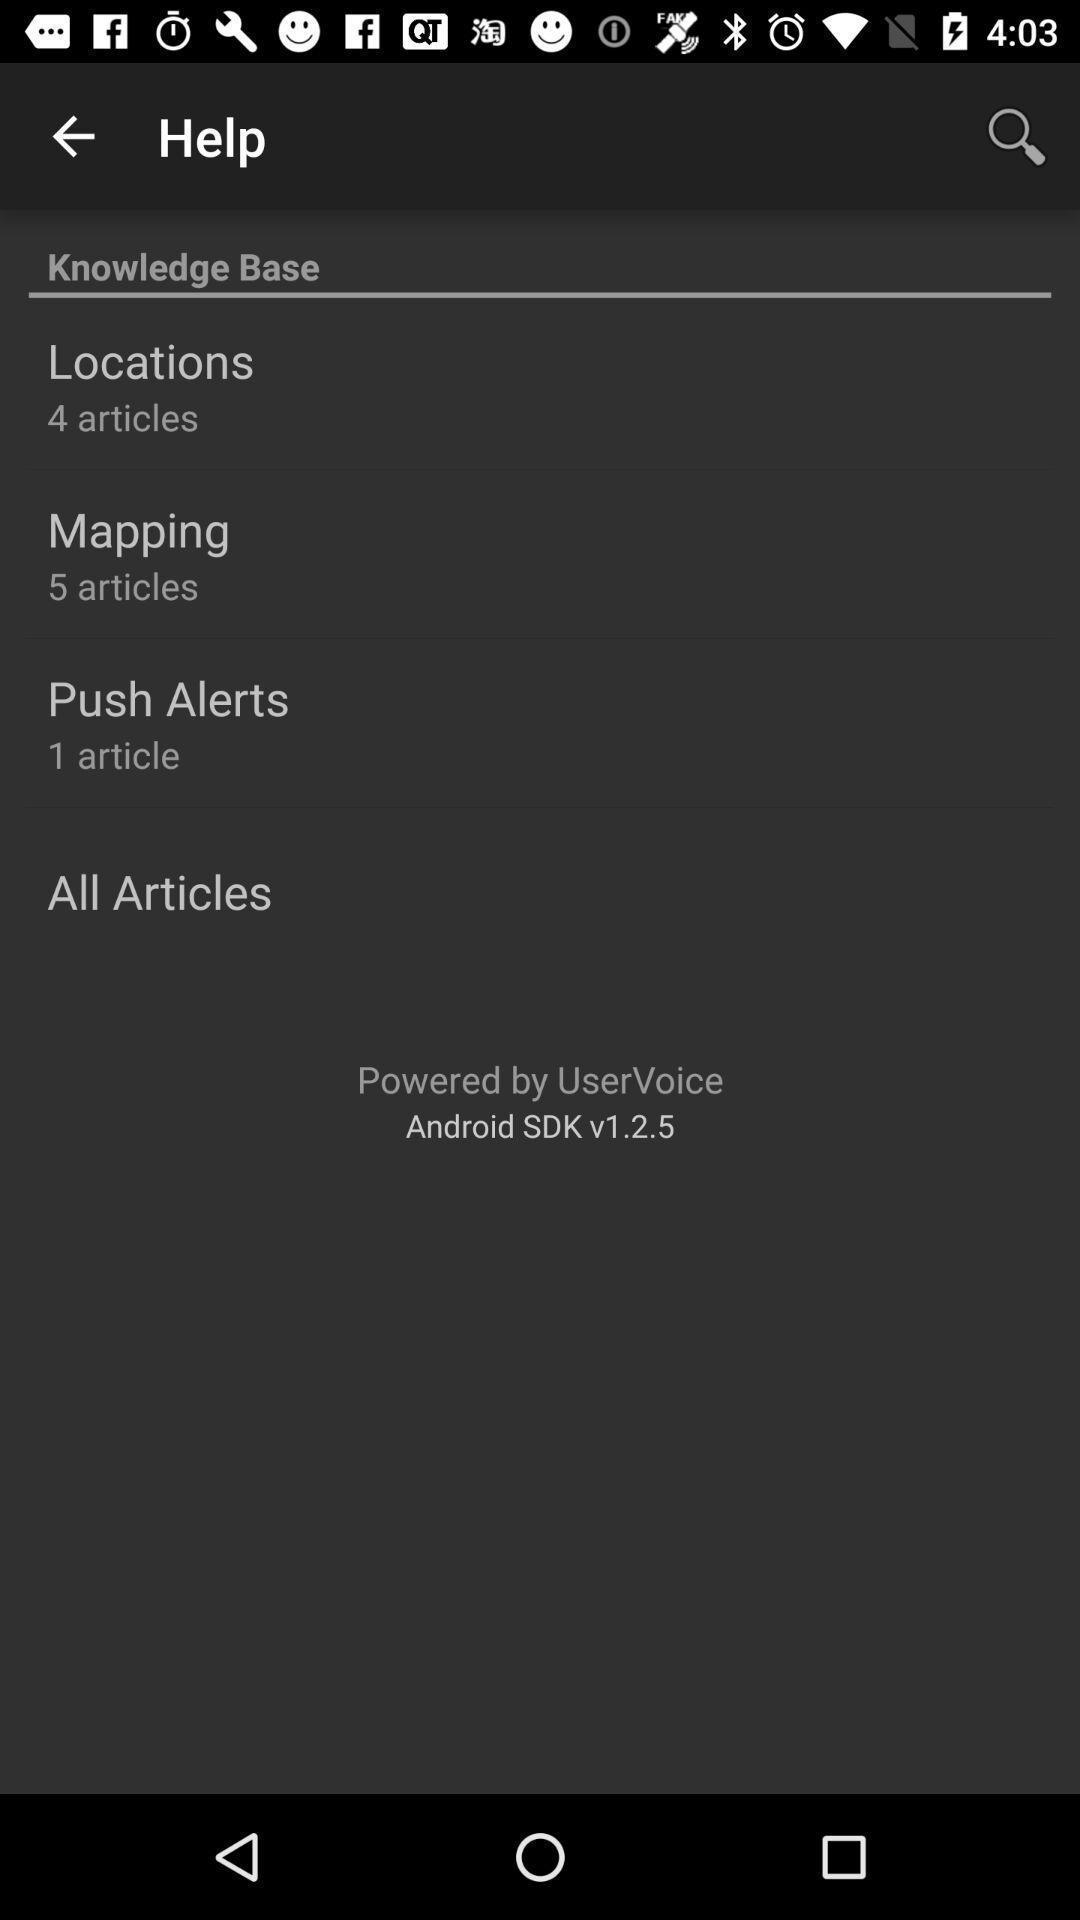Give me a narrative description of this picture. Screen showing help page. 